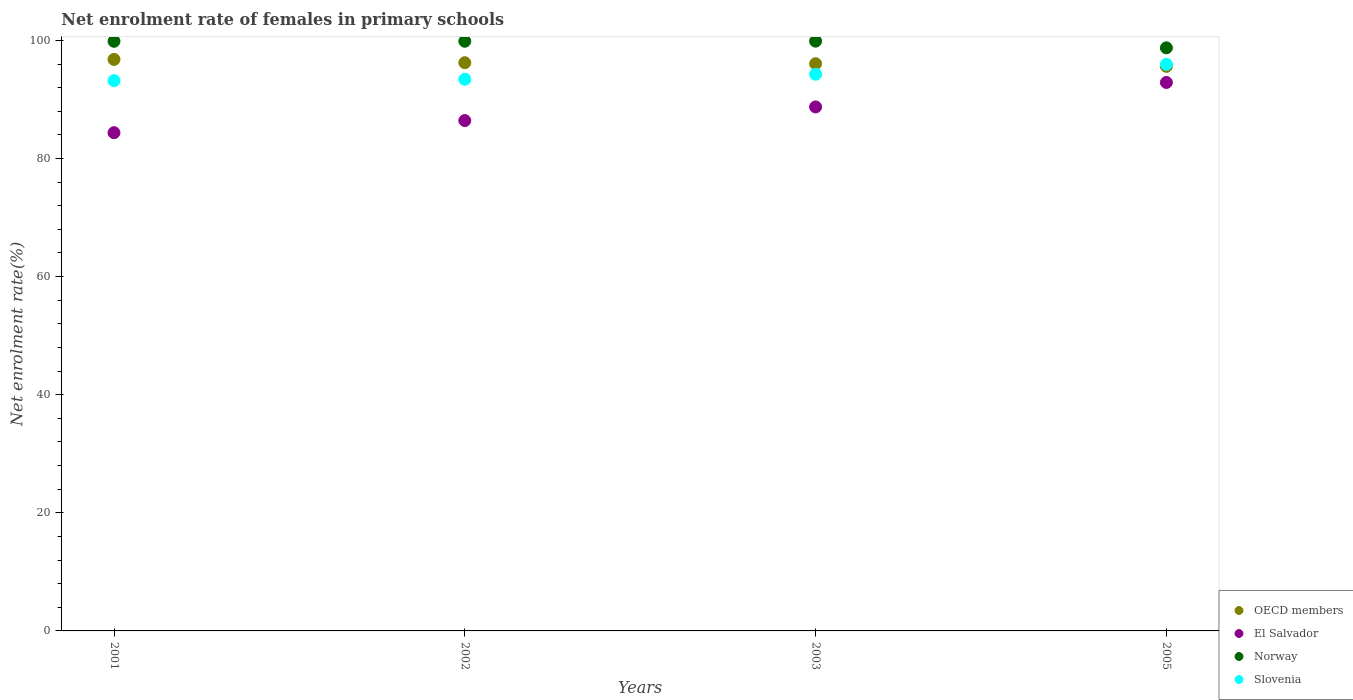How many different coloured dotlines are there?
Provide a succinct answer. 4. What is the net enrolment rate of females in primary schools in Slovenia in 2002?
Offer a very short reply. 93.42. Across all years, what is the maximum net enrolment rate of females in primary schools in OECD members?
Provide a succinct answer. 96.78. Across all years, what is the minimum net enrolment rate of females in primary schools in Slovenia?
Your response must be concise. 93.19. In which year was the net enrolment rate of females in primary schools in Slovenia maximum?
Make the answer very short. 2005. What is the total net enrolment rate of females in primary schools in Slovenia in the graph?
Make the answer very short. 376.82. What is the difference between the net enrolment rate of females in primary schools in El Salvador in 2001 and that in 2005?
Your answer should be compact. -8.5. What is the difference between the net enrolment rate of females in primary schools in OECD members in 2002 and the net enrolment rate of females in primary schools in Norway in 2001?
Provide a short and direct response. -3.62. What is the average net enrolment rate of females in primary schools in Norway per year?
Offer a very short reply. 99.58. In the year 2001, what is the difference between the net enrolment rate of females in primary schools in OECD members and net enrolment rate of females in primary schools in El Salvador?
Provide a short and direct response. 12.41. What is the ratio of the net enrolment rate of females in primary schools in Slovenia in 2001 to that in 2005?
Provide a short and direct response. 0.97. What is the difference between the highest and the second highest net enrolment rate of females in primary schools in Norway?
Your response must be concise. 0.02. What is the difference between the highest and the lowest net enrolment rate of females in primary schools in El Salvador?
Keep it short and to the point. 8.5. Is the sum of the net enrolment rate of females in primary schools in Slovenia in 2002 and 2005 greater than the maximum net enrolment rate of females in primary schools in OECD members across all years?
Give a very brief answer. Yes. Is it the case that in every year, the sum of the net enrolment rate of females in primary schools in Norway and net enrolment rate of females in primary schools in OECD members  is greater than the net enrolment rate of females in primary schools in El Salvador?
Your answer should be very brief. Yes. Does the net enrolment rate of females in primary schools in Norway monotonically increase over the years?
Ensure brevity in your answer.  No. Is the net enrolment rate of females in primary schools in Norway strictly greater than the net enrolment rate of females in primary schools in Slovenia over the years?
Ensure brevity in your answer.  Yes. Is the net enrolment rate of females in primary schools in Norway strictly less than the net enrolment rate of females in primary schools in OECD members over the years?
Keep it short and to the point. No. Does the graph contain any zero values?
Your answer should be very brief. No. How many legend labels are there?
Offer a very short reply. 4. What is the title of the graph?
Offer a terse response. Net enrolment rate of females in primary schools. Does "Northern Mariana Islands" appear as one of the legend labels in the graph?
Offer a terse response. No. What is the label or title of the X-axis?
Provide a succinct answer. Years. What is the label or title of the Y-axis?
Offer a terse response. Net enrolment rate(%). What is the Net enrolment rate(%) in OECD members in 2001?
Make the answer very short. 96.78. What is the Net enrolment rate(%) of El Salvador in 2001?
Make the answer very short. 84.37. What is the Net enrolment rate(%) of Norway in 2001?
Your response must be concise. 99.85. What is the Net enrolment rate(%) in Slovenia in 2001?
Offer a terse response. 93.19. What is the Net enrolment rate(%) in OECD members in 2002?
Offer a very short reply. 96.22. What is the Net enrolment rate(%) in El Salvador in 2002?
Your answer should be compact. 86.43. What is the Net enrolment rate(%) in Norway in 2002?
Your answer should be compact. 99.86. What is the Net enrolment rate(%) in Slovenia in 2002?
Your answer should be very brief. 93.42. What is the Net enrolment rate(%) of OECD members in 2003?
Give a very brief answer. 96.05. What is the Net enrolment rate(%) of El Salvador in 2003?
Keep it short and to the point. 88.73. What is the Net enrolment rate(%) in Norway in 2003?
Provide a short and direct response. 99.87. What is the Net enrolment rate(%) in Slovenia in 2003?
Provide a succinct answer. 94.27. What is the Net enrolment rate(%) in OECD members in 2005?
Offer a terse response. 95.61. What is the Net enrolment rate(%) of El Salvador in 2005?
Provide a succinct answer. 92.88. What is the Net enrolment rate(%) in Norway in 2005?
Your answer should be compact. 98.74. What is the Net enrolment rate(%) of Slovenia in 2005?
Your answer should be very brief. 95.94. Across all years, what is the maximum Net enrolment rate(%) of OECD members?
Give a very brief answer. 96.78. Across all years, what is the maximum Net enrolment rate(%) of El Salvador?
Provide a succinct answer. 92.88. Across all years, what is the maximum Net enrolment rate(%) in Norway?
Offer a terse response. 99.87. Across all years, what is the maximum Net enrolment rate(%) in Slovenia?
Keep it short and to the point. 95.94. Across all years, what is the minimum Net enrolment rate(%) in OECD members?
Provide a succinct answer. 95.61. Across all years, what is the minimum Net enrolment rate(%) of El Salvador?
Make the answer very short. 84.37. Across all years, what is the minimum Net enrolment rate(%) in Norway?
Ensure brevity in your answer.  98.74. Across all years, what is the minimum Net enrolment rate(%) in Slovenia?
Offer a terse response. 93.19. What is the total Net enrolment rate(%) of OECD members in the graph?
Keep it short and to the point. 384.66. What is the total Net enrolment rate(%) in El Salvador in the graph?
Make the answer very short. 352.41. What is the total Net enrolment rate(%) of Norway in the graph?
Provide a short and direct response. 398.32. What is the total Net enrolment rate(%) in Slovenia in the graph?
Keep it short and to the point. 376.82. What is the difference between the Net enrolment rate(%) in OECD members in 2001 and that in 2002?
Offer a very short reply. 0.55. What is the difference between the Net enrolment rate(%) of El Salvador in 2001 and that in 2002?
Offer a terse response. -2.05. What is the difference between the Net enrolment rate(%) of Norway in 2001 and that in 2002?
Provide a short and direct response. -0.01. What is the difference between the Net enrolment rate(%) of Slovenia in 2001 and that in 2002?
Offer a terse response. -0.24. What is the difference between the Net enrolment rate(%) in OECD members in 2001 and that in 2003?
Offer a very short reply. 0.72. What is the difference between the Net enrolment rate(%) in El Salvador in 2001 and that in 2003?
Provide a short and direct response. -4.36. What is the difference between the Net enrolment rate(%) in Norway in 2001 and that in 2003?
Your answer should be compact. -0.02. What is the difference between the Net enrolment rate(%) of Slovenia in 2001 and that in 2003?
Give a very brief answer. -1.08. What is the difference between the Net enrolment rate(%) in OECD members in 2001 and that in 2005?
Ensure brevity in your answer.  1.17. What is the difference between the Net enrolment rate(%) in El Salvador in 2001 and that in 2005?
Ensure brevity in your answer.  -8.5. What is the difference between the Net enrolment rate(%) in Norway in 2001 and that in 2005?
Provide a short and direct response. 1.11. What is the difference between the Net enrolment rate(%) in Slovenia in 2001 and that in 2005?
Make the answer very short. -2.76. What is the difference between the Net enrolment rate(%) of OECD members in 2002 and that in 2003?
Provide a short and direct response. 0.17. What is the difference between the Net enrolment rate(%) of El Salvador in 2002 and that in 2003?
Provide a short and direct response. -2.31. What is the difference between the Net enrolment rate(%) of Norway in 2002 and that in 2003?
Keep it short and to the point. -0.02. What is the difference between the Net enrolment rate(%) in Slovenia in 2002 and that in 2003?
Offer a very short reply. -0.85. What is the difference between the Net enrolment rate(%) in OECD members in 2002 and that in 2005?
Provide a short and direct response. 0.62. What is the difference between the Net enrolment rate(%) of El Salvador in 2002 and that in 2005?
Your response must be concise. -6.45. What is the difference between the Net enrolment rate(%) in Norway in 2002 and that in 2005?
Provide a succinct answer. 1.11. What is the difference between the Net enrolment rate(%) in Slovenia in 2002 and that in 2005?
Make the answer very short. -2.52. What is the difference between the Net enrolment rate(%) in OECD members in 2003 and that in 2005?
Give a very brief answer. 0.45. What is the difference between the Net enrolment rate(%) in El Salvador in 2003 and that in 2005?
Your answer should be compact. -4.14. What is the difference between the Net enrolment rate(%) of Norway in 2003 and that in 2005?
Offer a very short reply. 1.13. What is the difference between the Net enrolment rate(%) in Slovenia in 2003 and that in 2005?
Provide a short and direct response. -1.68. What is the difference between the Net enrolment rate(%) of OECD members in 2001 and the Net enrolment rate(%) of El Salvador in 2002?
Provide a short and direct response. 10.35. What is the difference between the Net enrolment rate(%) in OECD members in 2001 and the Net enrolment rate(%) in Norway in 2002?
Ensure brevity in your answer.  -3.08. What is the difference between the Net enrolment rate(%) of OECD members in 2001 and the Net enrolment rate(%) of Slovenia in 2002?
Your answer should be compact. 3.36. What is the difference between the Net enrolment rate(%) in El Salvador in 2001 and the Net enrolment rate(%) in Norway in 2002?
Offer a terse response. -15.48. What is the difference between the Net enrolment rate(%) of El Salvador in 2001 and the Net enrolment rate(%) of Slovenia in 2002?
Provide a short and direct response. -9.05. What is the difference between the Net enrolment rate(%) in Norway in 2001 and the Net enrolment rate(%) in Slovenia in 2002?
Your answer should be compact. 6.43. What is the difference between the Net enrolment rate(%) of OECD members in 2001 and the Net enrolment rate(%) of El Salvador in 2003?
Your response must be concise. 8.05. What is the difference between the Net enrolment rate(%) in OECD members in 2001 and the Net enrolment rate(%) in Norway in 2003?
Provide a short and direct response. -3.09. What is the difference between the Net enrolment rate(%) in OECD members in 2001 and the Net enrolment rate(%) in Slovenia in 2003?
Your response must be concise. 2.51. What is the difference between the Net enrolment rate(%) of El Salvador in 2001 and the Net enrolment rate(%) of Norway in 2003?
Offer a very short reply. -15.5. What is the difference between the Net enrolment rate(%) in El Salvador in 2001 and the Net enrolment rate(%) in Slovenia in 2003?
Your response must be concise. -9.9. What is the difference between the Net enrolment rate(%) in Norway in 2001 and the Net enrolment rate(%) in Slovenia in 2003?
Your answer should be compact. 5.58. What is the difference between the Net enrolment rate(%) in OECD members in 2001 and the Net enrolment rate(%) in El Salvador in 2005?
Your answer should be compact. 3.9. What is the difference between the Net enrolment rate(%) of OECD members in 2001 and the Net enrolment rate(%) of Norway in 2005?
Your answer should be compact. -1.96. What is the difference between the Net enrolment rate(%) in OECD members in 2001 and the Net enrolment rate(%) in Slovenia in 2005?
Your response must be concise. 0.83. What is the difference between the Net enrolment rate(%) of El Salvador in 2001 and the Net enrolment rate(%) of Norway in 2005?
Keep it short and to the point. -14.37. What is the difference between the Net enrolment rate(%) in El Salvador in 2001 and the Net enrolment rate(%) in Slovenia in 2005?
Your answer should be compact. -11.57. What is the difference between the Net enrolment rate(%) in Norway in 2001 and the Net enrolment rate(%) in Slovenia in 2005?
Offer a terse response. 3.91. What is the difference between the Net enrolment rate(%) in OECD members in 2002 and the Net enrolment rate(%) in El Salvador in 2003?
Provide a succinct answer. 7.49. What is the difference between the Net enrolment rate(%) in OECD members in 2002 and the Net enrolment rate(%) in Norway in 2003?
Provide a succinct answer. -3.65. What is the difference between the Net enrolment rate(%) of OECD members in 2002 and the Net enrolment rate(%) of Slovenia in 2003?
Your answer should be compact. 1.96. What is the difference between the Net enrolment rate(%) in El Salvador in 2002 and the Net enrolment rate(%) in Norway in 2003?
Your response must be concise. -13.45. What is the difference between the Net enrolment rate(%) in El Salvador in 2002 and the Net enrolment rate(%) in Slovenia in 2003?
Your response must be concise. -7.84. What is the difference between the Net enrolment rate(%) of Norway in 2002 and the Net enrolment rate(%) of Slovenia in 2003?
Offer a terse response. 5.59. What is the difference between the Net enrolment rate(%) in OECD members in 2002 and the Net enrolment rate(%) in El Salvador in 2005?
Offer a very short reply. 3.35. What is the difference between the Net enrolment rate(%) of OECD members in 2002 and the Net enrolment rate(%) of Norway in 2005?
Provide a succinct answer. -2.52. What is the difference between the Net enrolment rate(%) in OECD members in 2002 and the Net enrolment rate(%) in Slovenia in 2005?
Your answer should be compact. 0.28. What is the difference between the Net enrolment rate(%) in El Salvador in 2002 and the Net enrolment rate(%) in Norway in 2005?
Keep it short and to the point. -12.32. What is the difference between the Net enrolment rate(%) in El Salvador in 2002 and the Net enrolment rate(%) in Slovenia in 2005?
Ensure brevity in your answer.  -9.52. What is the difference between the Net enrolment rate(%) of Norway in 2002 and the Net enrolment rate(%) of Slovenia in 2005?
Provide a short and direct response. 3.91. What is the difference between the Net enrolment rate(%) in OECD members in 2003 and the Net enrolment rate(%) in El Salvador in 2005?
Make the answer very short. 3.18. What is the difference between the Net enrolment rate(%) of OECD members in 2003 and the Net enrolment rate(%) of Norway in 2005?
Ensure brevity in your answer.  -2.69. What is the difference between the Net enrolment rate(%) of OECD members in 2003 and the Net enrolment rate(%) of Slovenia in 2005?
Make the answer very short. 0.11. What is the difference between the Net enrolment rate(%) in El Salvador in 2003 and the Net enrolment rate(%) in Norway in 2005?
Ensure brevity in your answer.  -10.01. What is the difference between the Net enrolment rate(%) of El Salvador in 2003 and the Net enrolment rate(%) of Slovenia in 2005?
Provide a short and direct response. -7.21. What is the difference between the Net enrolment rate(%) of Norway in 2003 and the Net enrolment rate(%) of Slovenia in 2005?
Make the answer very short. 3.93. What is the average Net enrolment rate(%) of OECD members per year?
Offer a terse response. 96.17. What is the average Net enrolment rate(%) of El Salvador per year?
Give a very brief answer. 88.1. What is the average Net enrolment rate(%) in Norway per year?
Offer a terse response. 99.58. What is the average Net enrolment rate(%) in Slovenia per year?
Your answer should be compact. 94.21. In the year 2001, what is the difference between the Net enrolment rate(%) of OECD members and Net enrolment rate(%) of El Salvador?
Provide a succinct answer. 12.41. In the year 2001, what is the difference between the Net enrolment rate(%) in OECD members and Net enrolment rate(%) in Norway?
Provide a short and direct response. -3.07. In the year 2001, what is the difference between the Net enrolment rate(%) in OECD members and Net enrolment rate(%) in Slovenia?
Your response must be concise. 3.59. In the year 2001, what is the difference between the Net enrolment rate(%) of El Salvador and Net enrolment rate(%) of Norway?
Make the answer very short. -15.48. In the year 2001, what is the difference between the Net enrolment rate(%) of El Salvador and Net enrolment rate(%) of Slovenia?
Offer a terse response. -8.81. In the year 2001, what is the difference between the Net enrolment rate(%) in Norway and Net enrolment rate(%) in Slovenia?
Offer a terse response. 6.66. In the year 2002, what is the difference between the Net enrolment rate(%) of OECD members and Net enrolment rate(%) of El Salvador?
Provide a succinct answer. 9.8. In the year 2002, what is the difference between the Net enrolment rate(%) in OECD members and Net enrolment rate(%) in Norway?
Your response must be concise. -3.63. In the year 2002, what is the difference between the Net enrolment rate(%) in OECD members and Net enrolment rate(%) in Slovenia?
Your answer should be very brief. 2.8. In the year 2002, what is the difference between the Net enrolment rate(%) of El Salvador and Net enrolment rate(%) of Norway?
Keep it short and to the point. -13.43. In the year 2002, what is the difference between the Net enrolment rate(%) of El Salvador and Net enrolment rate(%) of Slovenia?
Offer a very short reply. -7. In the year 2002, what is the difference between the Net enrolment rate(%) of Norway and Net enrolment rate(%) of Slovenia?
Offer a terse response. 6.43. In the year 2003, what is the difference between the Net enrolment rate(%) of OECD members and Net enrolment rate(%) of El Salvador?
Your answer should be very brief. 7.32. In the year 2003, what is the difference between the Net enrolment rate(%) of OECD members and Net enrolment rate(%) of Norway?
Your answer should be very brief. -3.82. In the year 2003, what is the difference between the Net enrolment rate(%) in OECD members and Net enrolment rate(%) in Slovenia?
Keep it short and to the point. 1.79. In the year 2003, what is the difference between the Net enrolment rate(%) of El Salvador and Net enrolment rate(%) of Norway?
Offer a terse response. -11.14. In the year 2003, what is the difference between the Net enrolment rate(%) of El Salvador and Net enrolment rate(%) of Slovenia?
Ensure brevity in your answer.  -5.54. In the year 2003, what is the difference between the Net enrolment rate(%) in Norway and Net enrolment rate(%) in Slovenia?
Give a very brief answer. 5.6. In the year 2005, what is the difference between the Net enrolment rate(%) in OECD members and Net enrolment rate(%) in El Salvador?
Make the answer very short. 2.73. In the year 2005, what is the difference between the Net enrolment rate(%) of OECD members and Net enrolment rate(%) of Norway?
Make the answer very short. -3.14. In the year 2005, what is the difference between the Net enrolment rate(%) in OECD members and Net enrolment rate(%) in Slovenia?
Your answer should be very brief. -0.34. In the year 2005, what is the difference between the Net enrolment rate(%) in El Salvador and Net enrolment rate(%) in Norway?
Offer a terse response. -5.87. In the year 2005, what is the difference between the Net enrolment rate(%) in El Salvador and Net enrolment rate(%) in Slovenia?
Your response must be concise. -3.07. In the year 2005, what is the difference between the Net enrolment rate(%) of Norway and Net enrolment rate(%) of Slovenia?
Keep it short and to the point. 2.8. What is the ratio of the Net enrolment rate(%) of OECD members in 2001 to that in 2002?
Ensure brevity in your answer.  1.01. What is the ratio of the Net enrolment rate(%) in El Salvador in 2001 to that in 2002?
Your answer should be compact. 0.98. What is the ratio of the Net enrolment rate(%) of Norway in 2001 to that in 2002?
Provide a short and direct response. 1. What is the ratio of the Net enrolment rate(%) in Slovenia in 2001 to that in 2002?
Your answer should be very brief. 1. What is the ratio of the Net enrolment rate(%) of OECD members in 2001 to that in 2003?
Offer a very short reply. 1.01. What is the ratio of the Net enrolment rate(%) of El Salvador in 2001 to that in 2003?
Provide a short and direct response. 0.95. What is the ratio of the Net enrolment rate(%) in Norway in 2001 to that in 2003?
Ensure brevity in your answer.  1. What is the ratio of the Net enrolment rate(%) in Slovenia in 2001 to that in 2003?
Your response must be concise. 0.99. What is the ratio of the Net enrolment rate(%) of OECD members in 2001 to that in 2005?
Your answer should be compact. 1.01. What is the ratio of the Net enrolment rate(%) of El Salvador in 2001 to that in 2005?
Your answer should be very brief. 0.91. What is the ratio of the Net enrolment rate(%) in Norway in 2001 to that in 2005?
Your answer should be compact. 1.01. What is the ratio of the Net enrolment rate(%) of Slovenia in 2001 to that in 2005?
Provide a succinct answer. 0.97. What is the ratio of the Net enrolment rate(%) in OECD members in 2002 to that in 2003?
Make the answer very short. 1. What is the ratio of the Net enrolment rate(%) of Norway in 2002 to that in 2003?
Your answer should be very brief. 1. What is the ratio of the Net enrolment rate(%) in Slovenia in 2002 to that in 2003?
Ensure brevity in your answer.  0.99. What is the ratio of the Net enrolment rate(%) in OECD members in 2002 to that in 2005?
Make the answer very short. 1.01. What is the ratio of the Net enrolment rate(%) of El Salvador in 2002 to that in 2005?
Provide a short and direct response. 0.93. What is the ratio of the Net enrolment rate(%) of Norway in 2002 to that in 2005?
Your answer should be very brief. 1.01. What is the ratio of the Net enrolment rate(%) in Slovenia in 2002 to that in 2005?
Keep it short and to the point. 0.97. What is the ratio of the Net enrolment rate(%) of OECD members in 2003 to that in 2005?
Ensure brevity in your answer.  1. What is the ratio of the Net enrolment rate(%) in El Salvador in 2003 to that in 2005?
Ensure brevity in your answer.  0.96. What is the ratio of the Net enrolment rate(%) in Norway in 2003 to that in 2005?
Provide a short and direct response. 1.01. What is the ratio of the Net enrolment rate(%) in Slovenia in 2003 to that in 2005?
Offer a very short reply. 0.98. What is the difference between the highest and the second highest Net enrolment rate(%) in OECD members?
Give a very brief answer. 0.55. What is the difference between the highest and the second highest Net enrolment rate(%) in El Salvador?
Ensure brevity in your answer.  4.14. What is the difference between the highest and the second highest Net enrolment rate(%) of Norway?
Your answer should be very brief. 0.02. What is the difference between the highest and the second highest Net enrolment rate(%) in Slovenia?
Keep it short and to the point. 1.68. What is the difference between the highest and the lowest Net enrolment rate(%) of OECD members?
Provide a succinct answer. 1.17. What is the difference between the highest and the lowest Net enrolment rate(%) in El Salvador?
Offer a very short reply. 8.5. What is the difference between the highest and the lowest Net enrolment rate(%) of Norway?
Offer a very short reply. 1.13. What is the difference between the highest and the lowest Net enrolment rate(%) in Slovenia?
Your answer should be very brief. 2.76. 